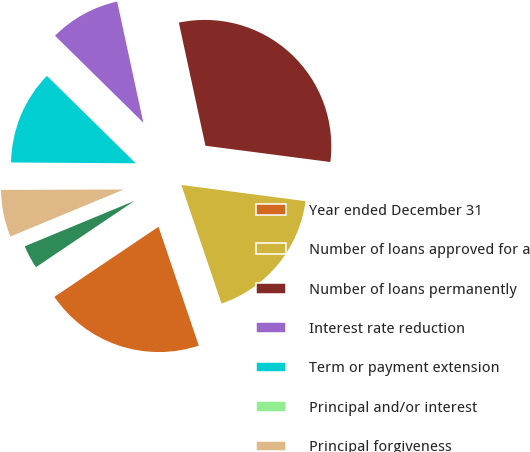<chart> <loc_0><loc_0><loc_500><loc_500><pie_chart><fcel>Year ended December 31<fcel>Number of loans approved for a<fcel>Number of loans permanently<fcel>Interest rate reduction<fcel>Term or payment extension<fcel>Principal and/or interest<fcel>Principal forgiveness<fcel>Other (b)<nl><fcel>20.77%<fcel>17.74%<fcel>30.45%<fcel>9.24%<fcel>12.27%<fcel>0.15%<fcel>6.21%<fcel>3.18%<nl></chart> 